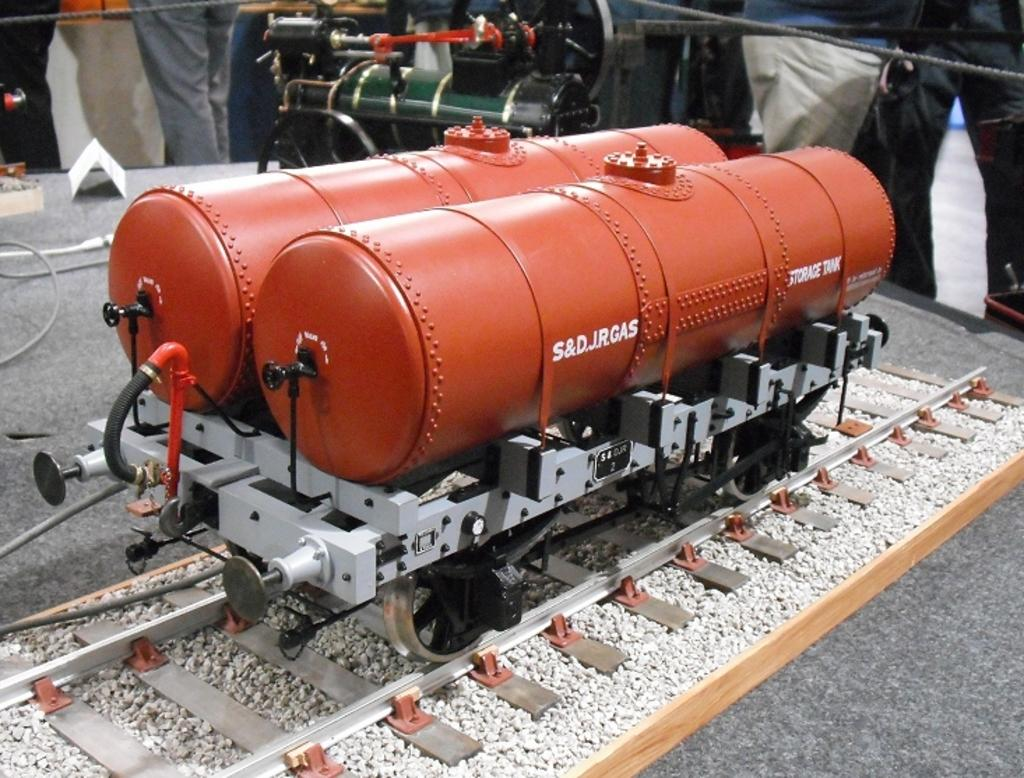What is the main subject of the image? There is a miniature in the image. What is featured in the miniature? There is a train engine in the miniature. Can you describe the people in the background of the image? There are people standing in the background of the image. What type of surface can be seen in the image? There are stones visible in the image. What is used for the train engine to move on? There is a track in the image. What type of cat can be seen sitting on the canvas in the image? There is no cat or canvas present in the image. What type of truck is visible in the image? There is no truck present in the image. 